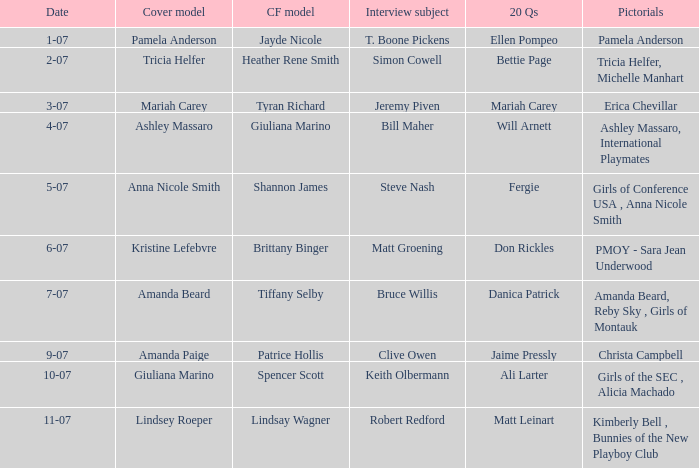Who was the centerfold model when the issue's pictorial was kimberly bell , bunnies of the new playboy club? Lindsay Wagner. 